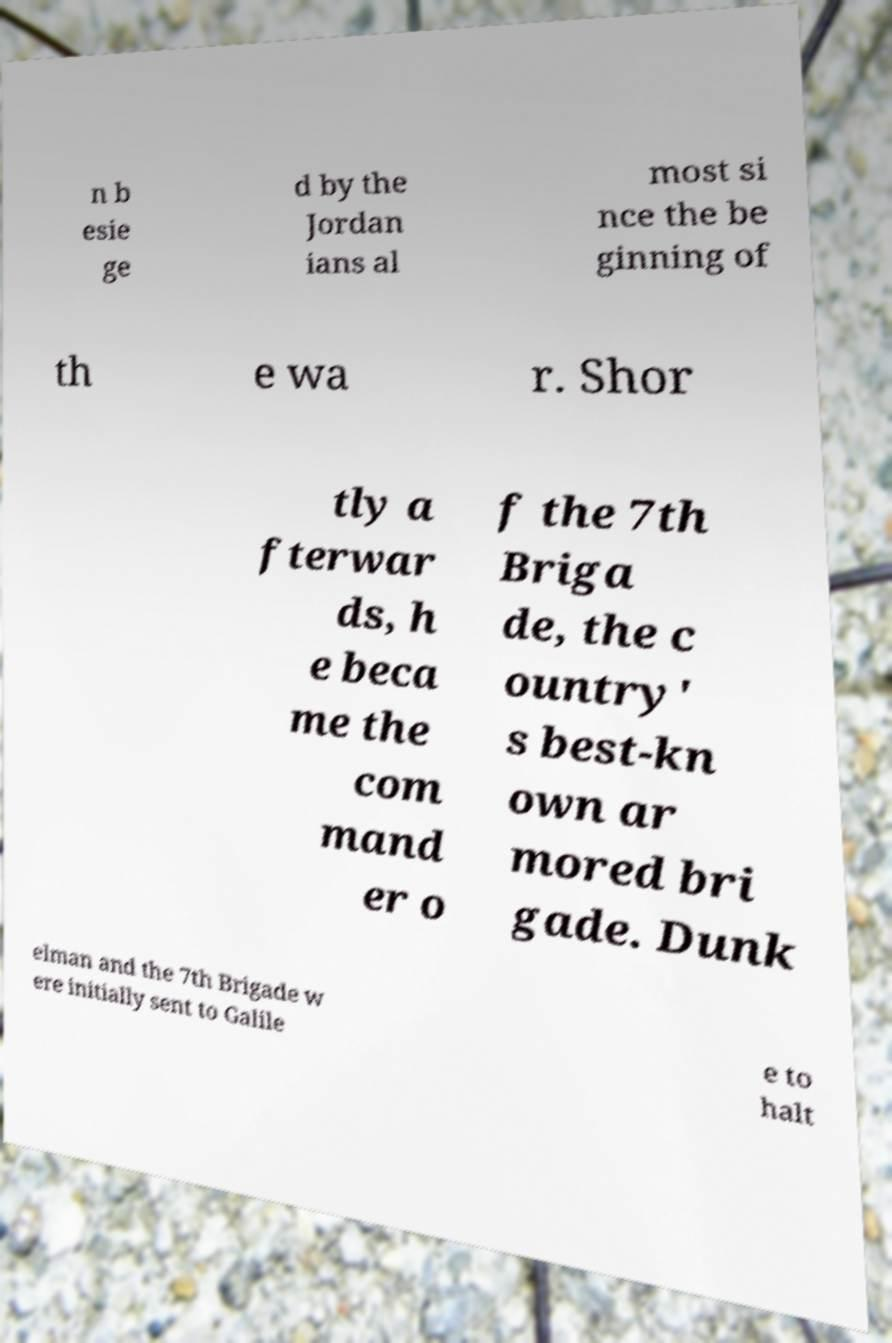What messages or text are displayed in this image? I need them in a readable, typed format. n b esie ge d by the Jordan ians al most si nce the be ginning of th e wa r. Shor tly a fterwar ds, h e beca me the com mand er o f the 7th Briga de, the c ountry' s best-kn own ar mored bri gade. Dunk elman and the 7th Brigade w ere initially sent to Galile e to halt 